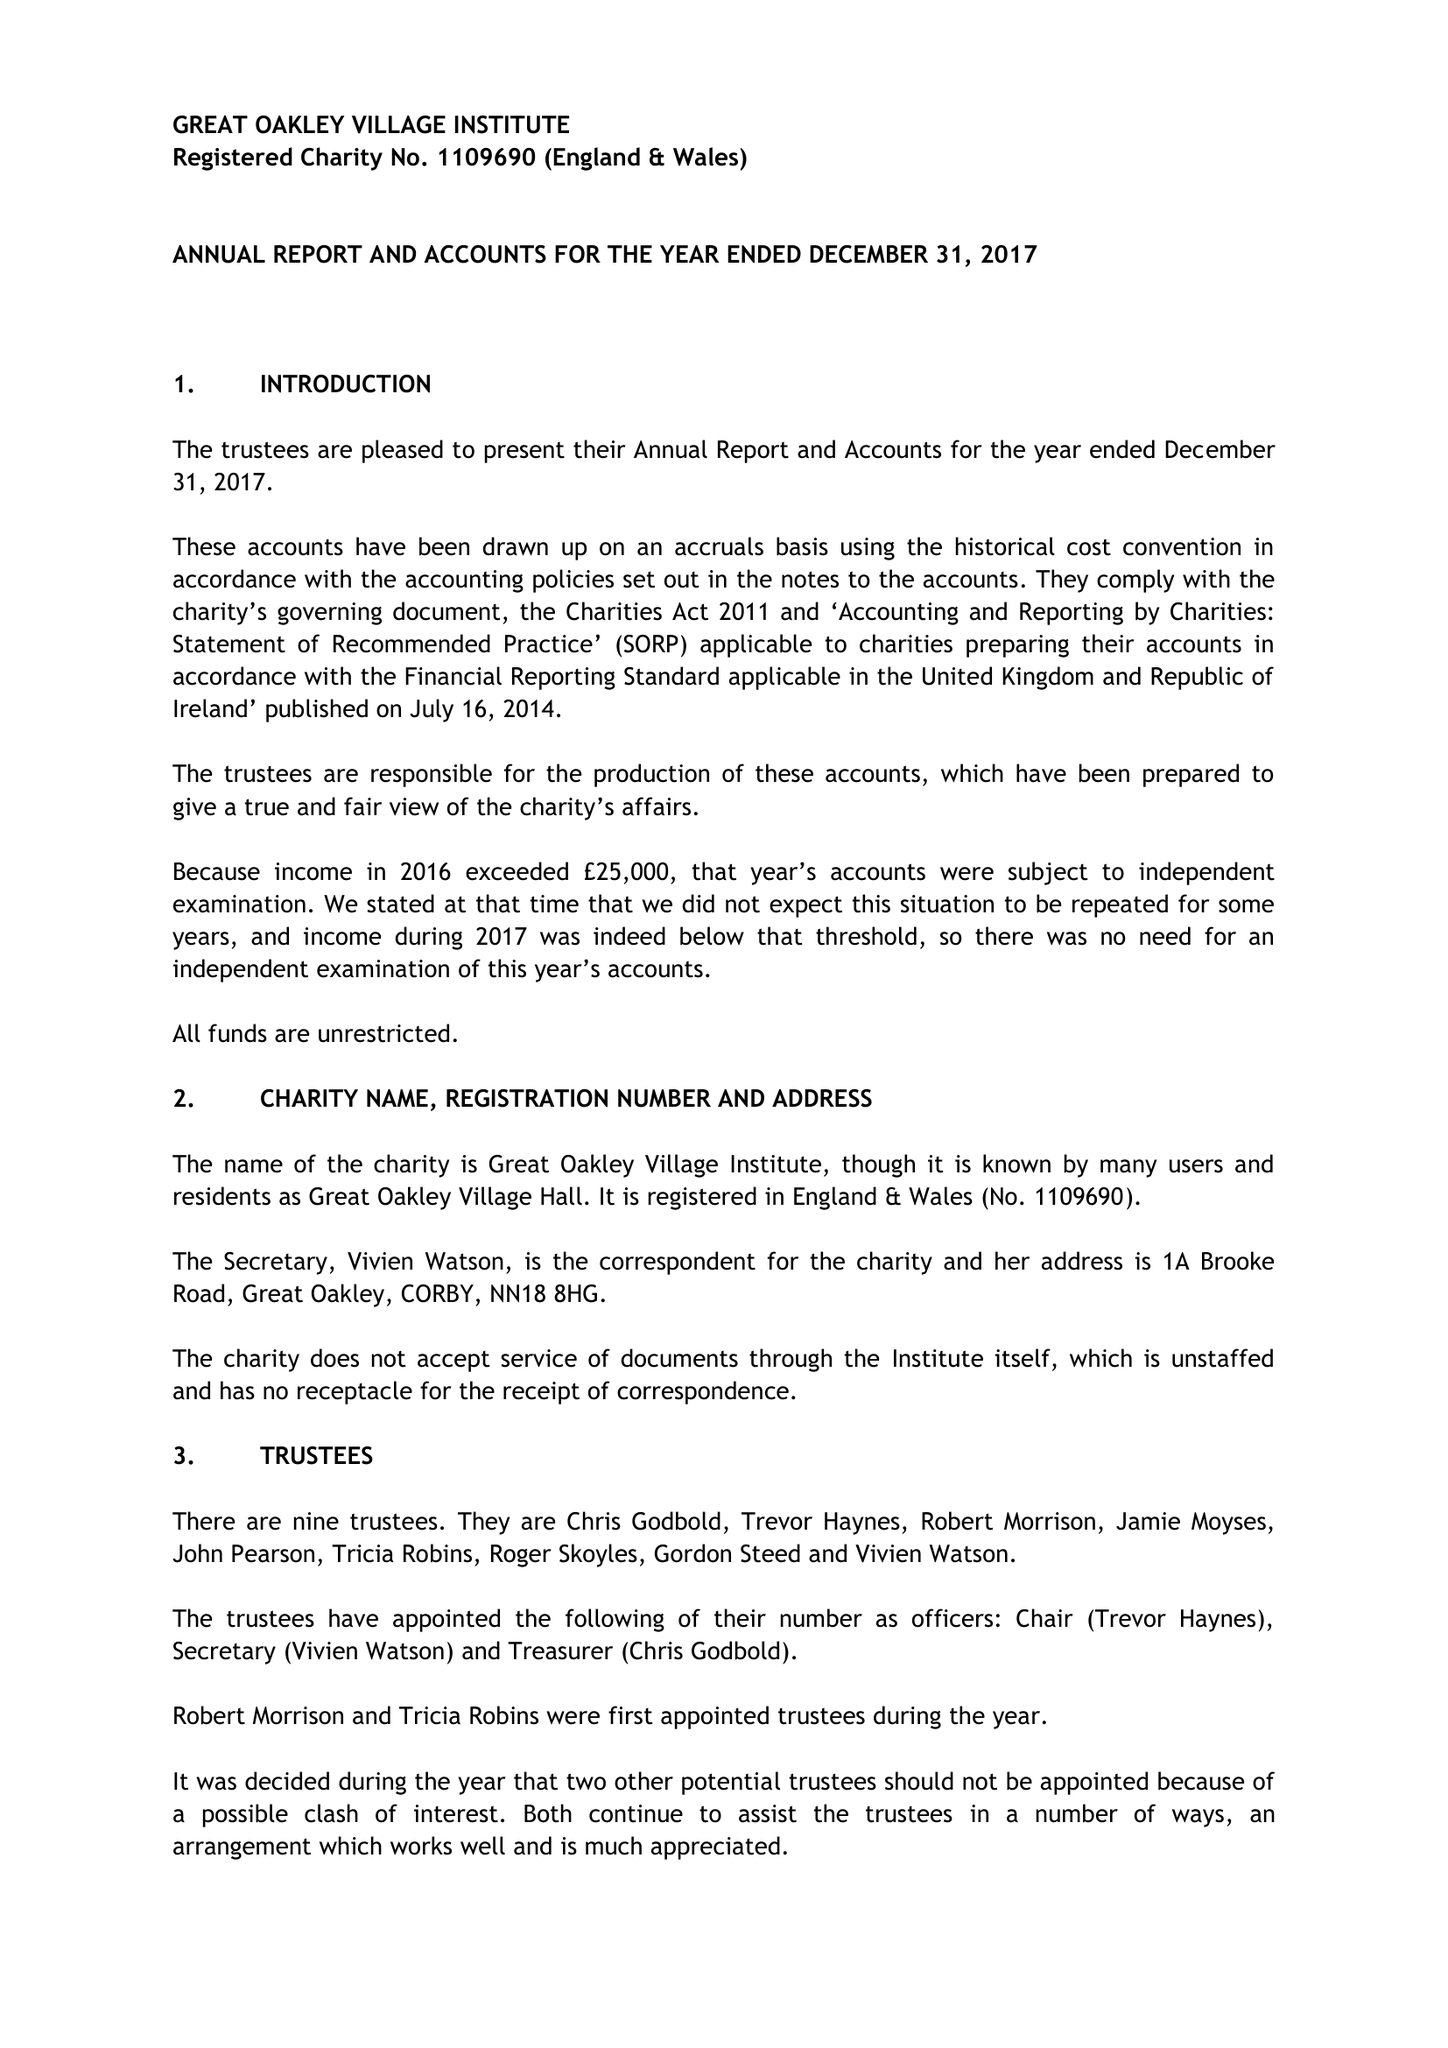What is the value for the address__street_line?
Answer the question using a single word or phrase. 1A BROOKE ROAD 